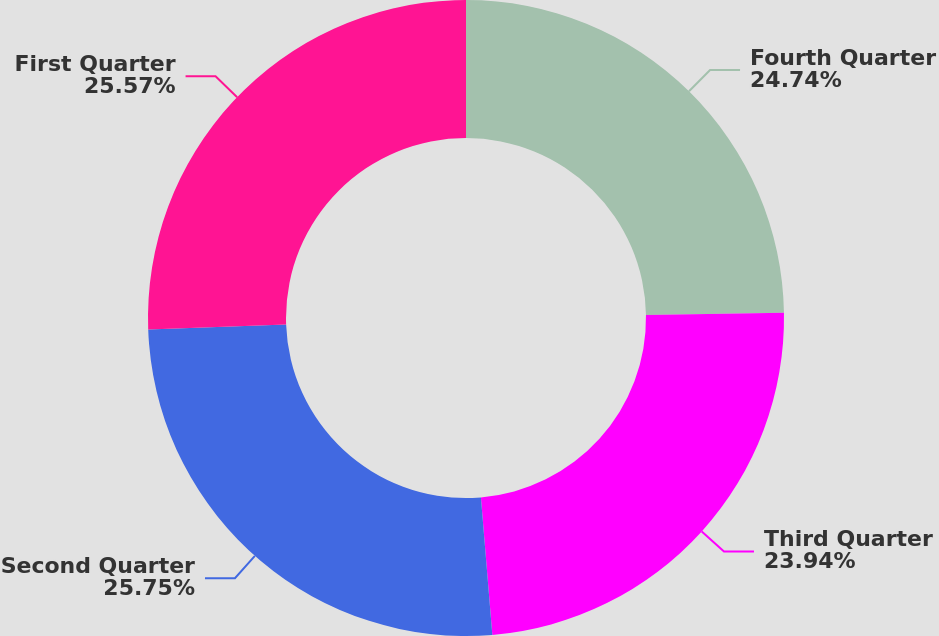Convert chart. <chart><loc_0><loc_0><loc_500><loc_500><pie_chart><fcel>Fourth Quarter<fcel>Third Quarter<fcel>Second Quarter<fcel>First Quarter<nl><fcel>24.74%<fcel>23.94%<fcel>25.75%<fcel>25.57%<nl></chart> 